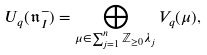<formula> <loc_0><loc_0><loc_500><loc_500>U _ { q } ( \mathfrak { n } _ { I } ^ { - } ) = \bigoplus _ { \mu \in \sum _ { j = 1 } ^ { n } \mathbb { Z } _ { \geq 0 } \lambda _ { j } } V _ { q } ( \mu ) ,</formula> 